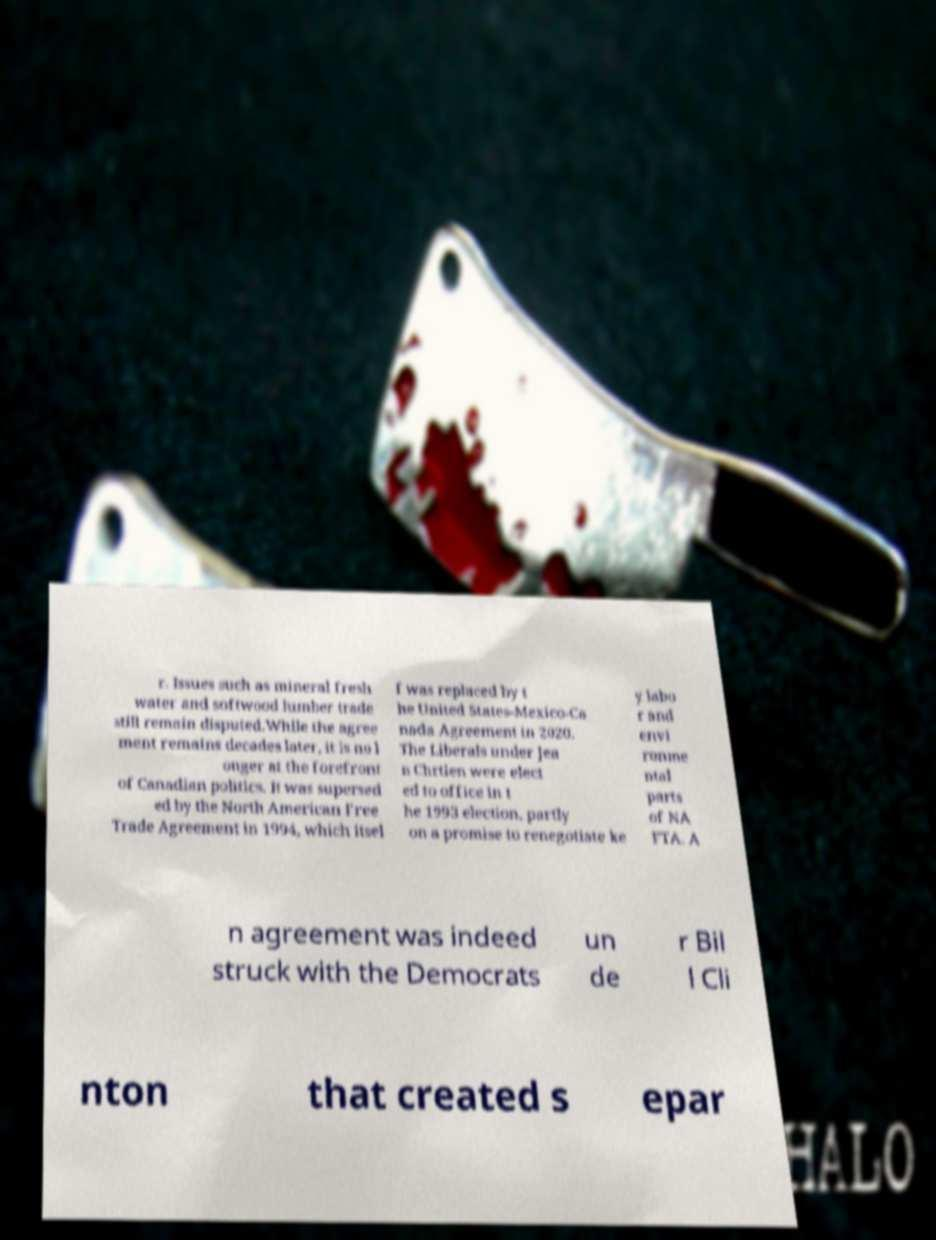What messages or text are displayed in this image? I need them in a readable, typed format. r. Issues such as mineral fresh water and softwood lumber trade still remain disputed.While the agree ment remains decades later, it is no l onger at the forefront of Canadian politics. It was supersed ed by the North American Free Trade Agreement in 1994, which itsel f was replaced by t he United States-Mexico-Ca nada Agreement in 2020. The Liberals under Jea n Chrtien were elect ed to office in t he 1993 election, partly on a promise to renegotiate ke y labo r and envi ronme ntal parts of NA FTA. A n agreement was indeed struck with the Democrats un de r Bil l Cli nton that created s epar 